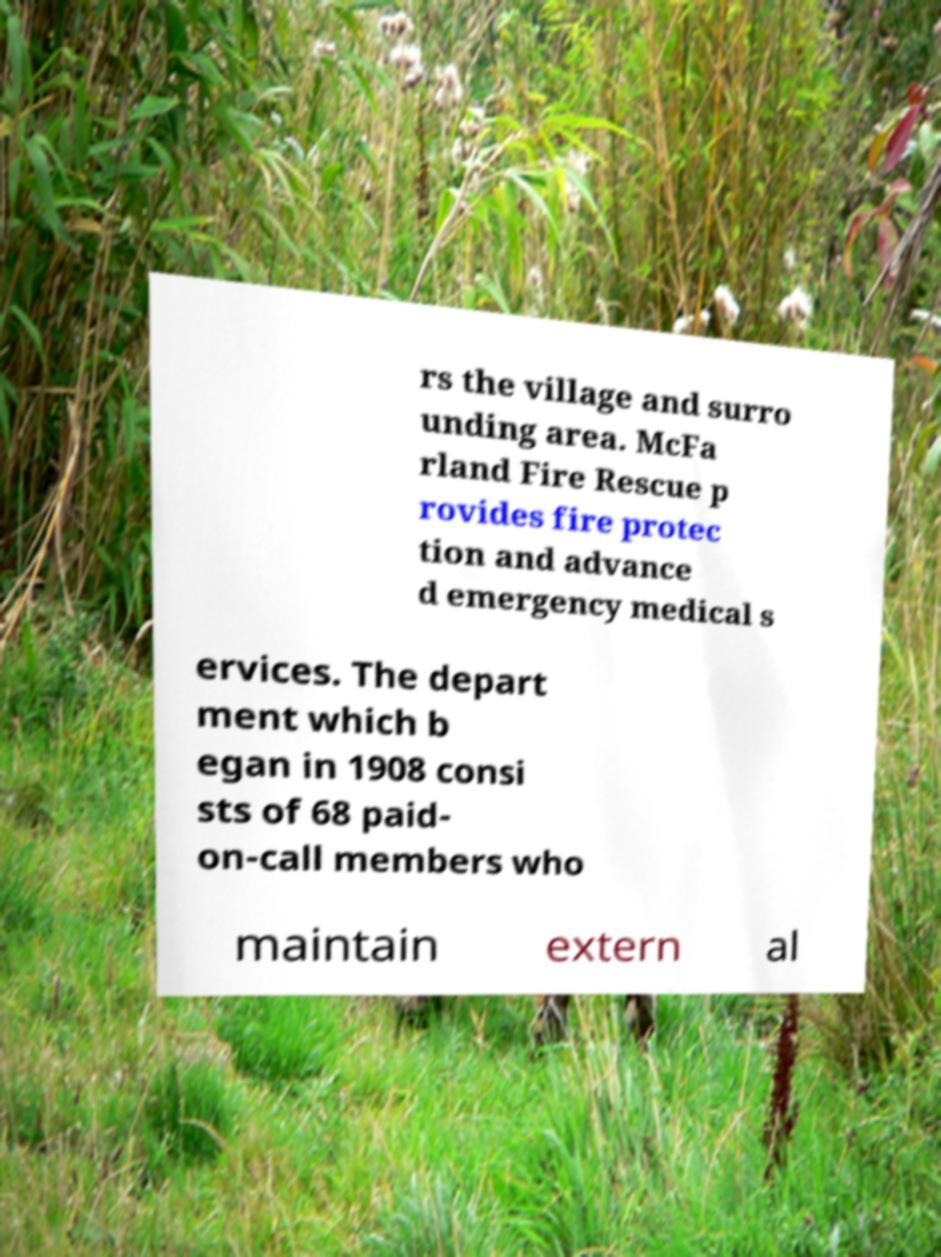Could you assist in decoding the text presented in this image and type it out clearly? rs the village and surro unding area. McFa rland Fire Rescue p rovides fire protec tion and advance d emergency medical s ervices. The depart ment which b egan in 1908 consi sts of 68 paid- on-call members who maintain extern al 